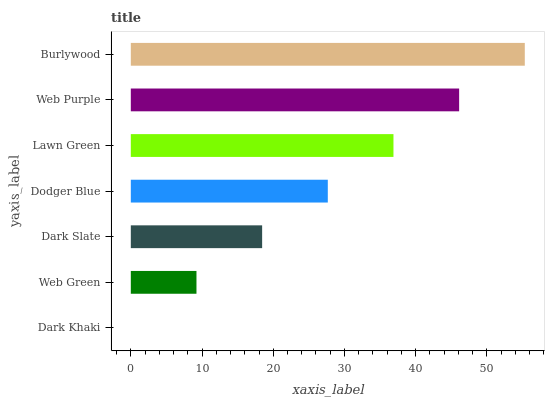Is Dark Khaki the minimum?
Answer yes or no. Yes. Is Burlywood the maximum?
Answer yes or no. Yes. Is Web Green the minimum?
Answer yes or no. No. Is Web Green the maximum?
Answer yes or no. No. Is Web Green greater than Dark Khaki?
Answer yes or no. Yes. Is Dark Khaki less than Web Green?
Answer yes or no. Yes. Is Dark Khaki greater than Web Green?
Answer yes or no. No. Is Web Green less than Dark Khaki?
Answer yes or no. No. Is Dodger Blue the high median?
Answer yes or no. Yes. Is Dodger Blue the low median?
Answer yes or no. Yes. Is Burlywood the high median?
Answer yes or no. No. Is Lawn Green the low median?
Answer yes or no. No. 